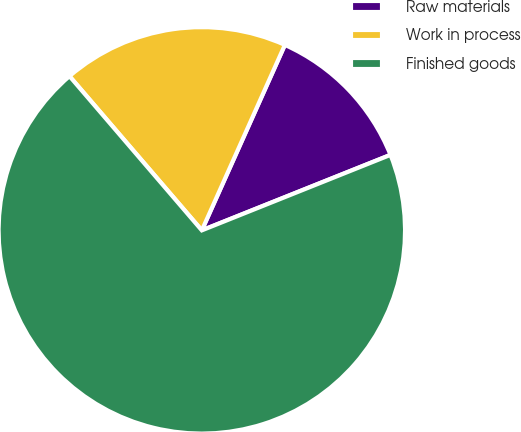<chart> <loc_0><loc_0><loc_500><loc_500><pie_chart><fcel>Raw materials<fcel>Work in process<fcel>Finished goods<nl><fcel>12.24%<fcel>17.99%<fcel>69.77%<nl></chart> 